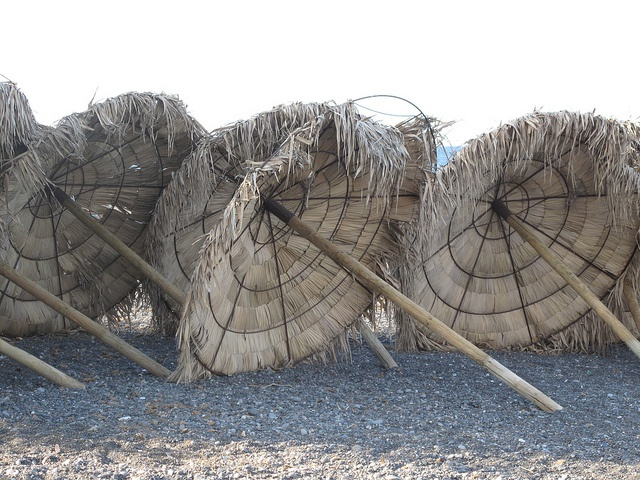Describe the objects in this image and their specific colors. I can see umbrella in white, gray, and darkgray tones, umbrella in white, gray, and darkgray tones, umbrella in white, gray, black, and darkgray tones, and umbrella in white, gray, darkgray, and black tones in this image. 